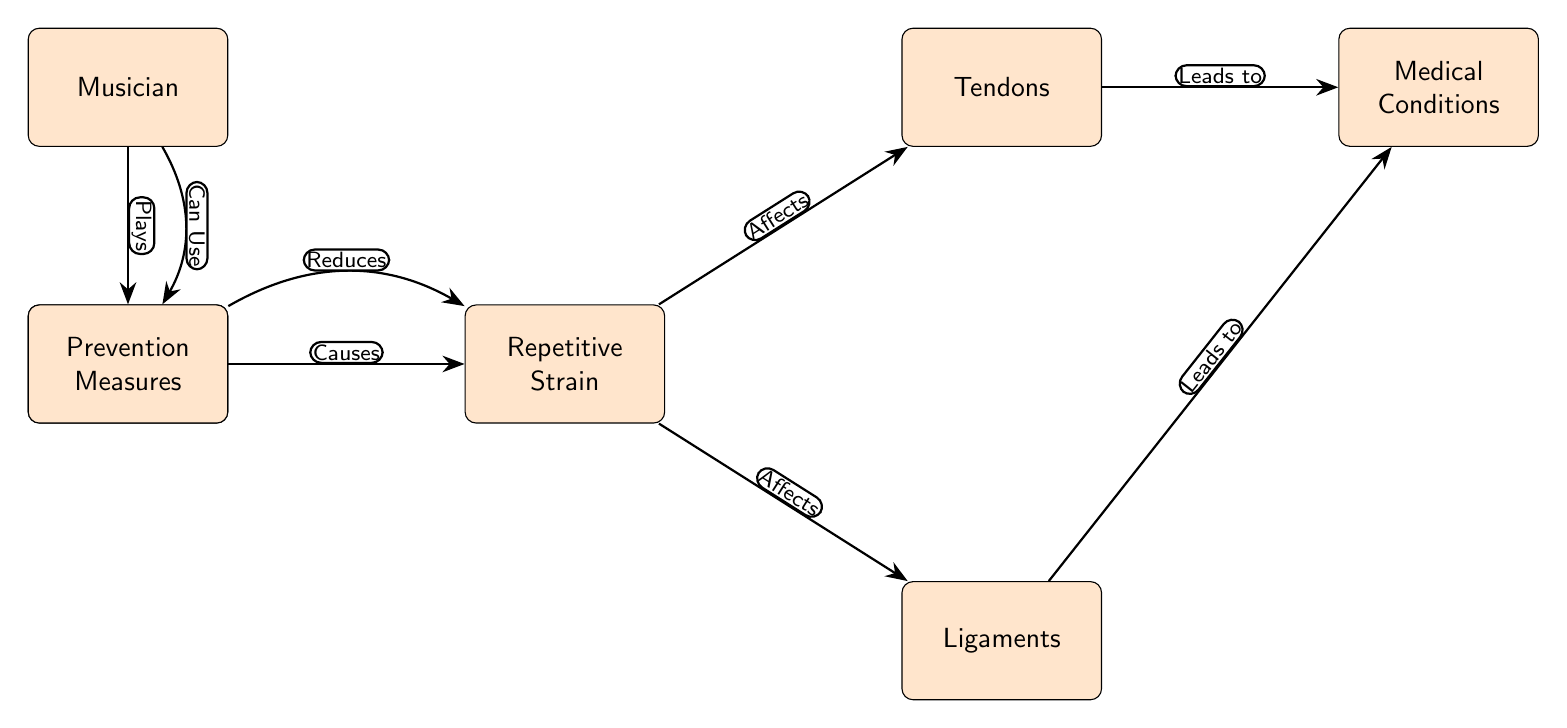What is the starting node of the diagram? The starting node, which serves as the entry point of the diagram's flow, is labeled "Musician."
Answer: Musician What does the "Traditional Instrument" lead to? The "Traditional Instrument" node leads to the "Repetitive Strain" node, as indicated by the edge labeled "Causes."
Answer: Repetitive Strain How many nodes are there in total? By counting each unique label in the diagram, we find there are six nodes: "Musician," "Traditional Instrument," "Repetitive Strain," "Tendons," "Ligaments," and "Medical Conditions."
Answer: Six What are the two conditions that "Repetitive Strain" affects? The "Repetitive Strain" node affects both "Tendons" and "Ligaments," as shown by the edges labeled "Affects."
Answer: Tendons and Ligaments Which node can the "Musician" use to prevent "Repetitive Strain"? The diagram indicates that the "Musician" can use the "Prevention Measures" node to potentially prevent "Repetitive Strain."
Answer: Prevention Measures Which medical conditions can both "Tendons" and "Ligaments" lead to? Both "Tendons" and "Ligaments" lead to the "Medical Conditions" node as indicated by the edges labeled "Leads to."
Answer: Medical Conditions How does the "Prevention Measures" node impact "Repetitive Strain"? The "Prevention Measures" node is connected to the "Repetitive Strain" node with an edge that states "Reduces," indicating a lowering of the strain.
Answer: Reduces How are "Tendons" and "Ligaments" connected to "Medical Conditions"? Both "Tendons" and "Ligaments" are connected to "Medical Conditions" through edges that denote they "Lead to" these conditions, reflecting a cause-and-effect relationship.
Answer: Lead to What action does the "Musician" take in relation to their instrument? The "Musician" plays the "Traditional Instrument," as shown by the edge labeled "Plays."
Answer: Plays 